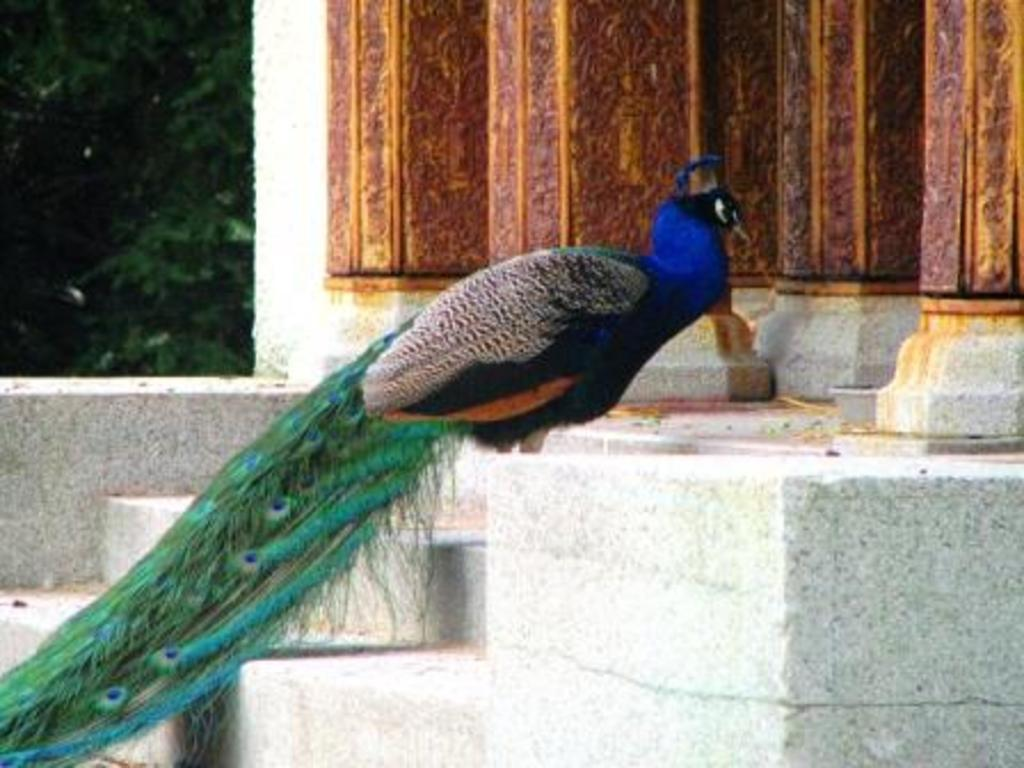What animal is the main subject of the image? There is a peacock in the image. Where is the peacock located in the image? The peacock is on the stairs. What can be seen in the background of the image? There are pillars, buildings, and trees in the background of the image. How many crooks are visible in the image? There are no crooks present in the image. What type of cats can be seen playing with bikes in the image? There are no cats or bikes present in the image. 